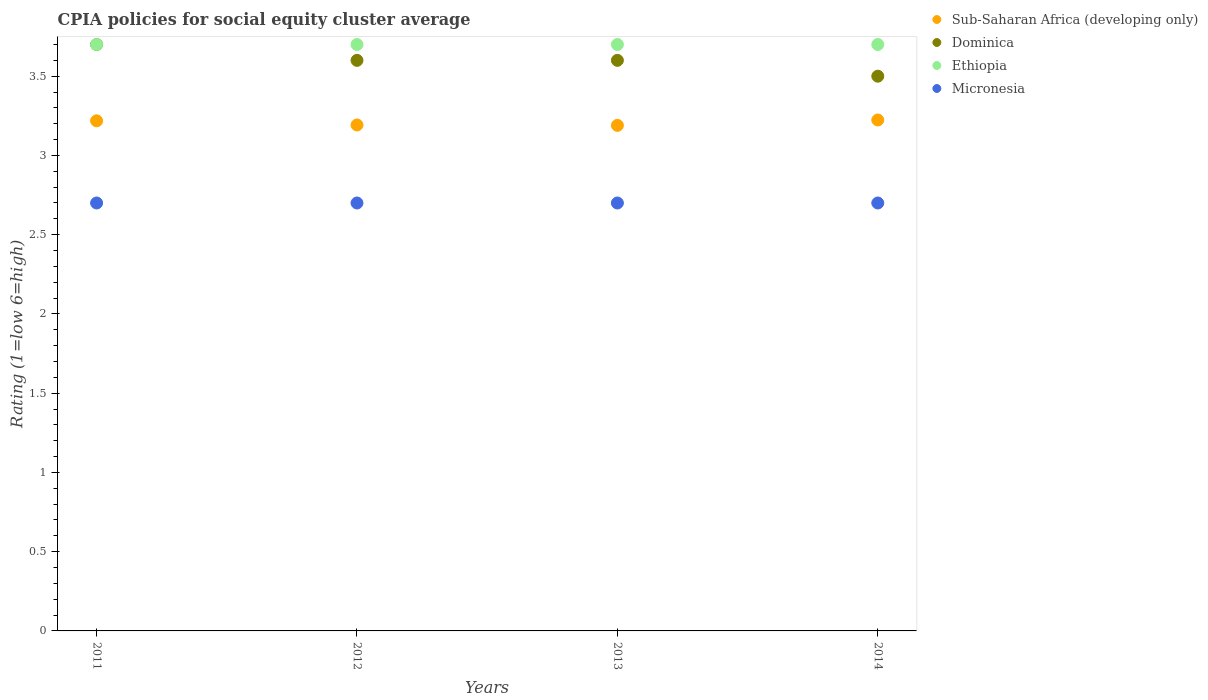How many different coloured dotlines are there?
Ensure brevity in your answer.  4. Is the number of dotlines equal to the number of legend labels?
Provide a succinct answer. Yes. Across all years, what is the maximum CPIA rating in Dominica?
Your answer should be very brief. 3.7. In which year was the CPIA rating in Dominica minimum?
Give a very brief answer. 2014. What is the total CPIA rating in Sub-Saharan Africa (developing only) in the graph?
Provide a short and direct response. 12.82. What is the difference between the CPIA rating in Sub-Saharan Africa (developing only) in 2013 and that in 2014?
Your answer should be very brief. -0.03. What is the difference between the CPIA rating in Micronesia in 2011 and the CPIA rating in Dominica in 2013?
Your response must be concise. -0.9. What is the average CPIA rating in Micronesia per year?
Make the answer very short. 2.7. In the year 2011, what is the difference between the CPIA rating in Ethiopia and CPIA rating in Micronesia?
Give a very brief answer. 1. What is the ratio of the CPIA rating in Dominica in 2013 to that in 2014?
Provide a short and direct response. 1.03. Is the CPIA rating in Micronesia in 2012 less than that in 2014?
Give a very brief answer. No. What is the difference between the highest and the second highest CPIA rating in Micronesia?
Offer a terse response. 0. In how many years, is the CPIA rating in Dominica greater than the average CPIA rating in Dominica taken over all years?
Give a very brief answer. 1. Is the CPIA rating in Sub-Saharan Africa (developing only) strictly greater than the CPIA rating in Micronesia over the years?
Provide a succinct answer. Yes. Is the CPIA rating in Ethiopia strictly less than the CPIA rating in Dominica over the years?
Offer a very short reply. No. How many dotlines are there?
Your response must be concise. 4. What is the difference between two consecutive major ticks on the Y-axis?
Provide a succinct answer. 0.5. Are the values on the major ticks of Y-axis written in scientific E-notation?
Offer a terse response. No. Does the graph contain grids?
Provide a succinct answer. No. Where does the legend appear in the graph?
Your answer should be very brief. Top right. How many legend labels are there?
Your answer should be very brief. 4. How are the legend labels stacked?
Offer a terse response. Vertical. What is the title of the graph?
Your answer should be very brief. CPIA policies for social equity cluster average. Does "Greece" appear as one of the legend labels in the graph?
Your response must be concise. No. What is the label or title of the X-axis?
Your answer should be very brief. Years. What is the label or title of the Y-axis?
Ensure brevity in your answer.  Rating (1=low 6=high). What is the Rating (1=low 6=high) of Sub-Saharan Africa (developing only) in 2011?
Make the answer very short. 3.22. What is the Rating (1=low 6=high) of Ethiopia in 2011?
Provide a short and direct response. 3.7. What is the Rating (1=low 6=high) in Micronesia in 2011?
Make the answer very short. 2.7. What is the Rating (1=low 6=high) of Sub-Saharan Africa (developing only) in 2012?
Offer a very short reply. 3.19. What is the Rating (1=low 6=high) of Sub-Saharan Africa (developing only) in 2013?
Your response must be concise. 3.19. What is the Rating (1=low 6=high) in Dominica in 2013?
Your response must be concise. 3.6. What is the Rating (1=low 6=high) in Sub-Saharan Africa (developing only) in 2014?
Provide a short and direct response. 3.22. What is the Rating (1=low 6=high) in Ethiopia in 2014?
Provide a succinct answer. 3.7. What is the Rating (1=low 6=high) in Micronesia in 2014?
Keep it short and to the point. 2.7. Across all years, what is the maximum Rating (1=low 6=high) of Sub-Saharan Africa (developing only)?
Ensure brevity in your answer.  3.22. Across all years, what is the maximum Rating (1=low 6=high) of Dominica?
Keep it short and to the point. 3.7. Across all years, what is the maximum Rating (1=low 6=high) of Ethiopia?
Provide a short and direct response. 3.7. Across all years, what is the minimum Rating (1=low 6=high) of Sub-Saharan Africa (developing only)?
Your response must be concise. 3.19. Across all years, what is the minimum Rating (1=low 6=high) of Ethiopia?
Offer a very short reply. 3.7. Across all years, what is the minimum Rating (1=low 6=high) of Micronesia?
Your answer should be very brief. 2.7. What is the total Rating (1=low 6=high) in Sub-Saharan Africa (developing only) in the graph?
Offer a very short reply. 12.82. What is the total Rating (1=low 6=high) of Dominica in the graph?
Your answer should be very brief. 14.4. What is the total Rating (1=low 6=high) in Ethiopia in the graph?
Ensure brevity in your answer.  14.8. What is the difference between the Rating (1=low 6=high) of Sub-Saharan Africa (developing only) in 2011 and that in 2012?
Your answer should be very brief. 0.03. What is the difference between the Rating (1=low 6=high) of Sub-Saharan Africa (developing only) in 2011 and that in 2013?
Ensure brevity in your answer.  0.03. What is the difference between the Rating (1=low 6=high) of Dominica in 2011 and that in 2013?
Provide a succinct answer. 0.1. What is the difference between the Rating (1=low 6=high) in Ethiopia in 2011 and that in 2013?
Provide a short and direct response. 0. What is the difference between the Rating (1=low 6=high) of Micronesia in 2011 and that in 2013?
Make the answer very short. 0. What is the difference between the Rating (1=low 6=high) of Sub-Saharan Africa (developing only) in 2011 and that in 2014?
Ensure brevity in your answer.  -0.01. What is the difference between the Rating (1=low 6=high) in Ethiopia in 2011 and that in 2014?
Give a very brief answer. 0. What is the difference between the Rating (1=low 6=high) in Micronesia in 2011 and that in 2014?
Offer a terse response. 0. What is the difference between the Rating (1=low 6=high) in Sub-Saharan Africa (developing only) in 2012 and that in 2013?
Your answer should be compact. 0. What is the difference between the Rating (1=low 6=high) of Dominica in 2012 and that in 2013?
Offer a very short reply. 0. What is the difference between the Rating (1=low 6=high) of Sub-Saharan Africa (developing only) in 2012 and that in 2014?
Offer a terse response. -0.03. What is the difference between the Rating (1=low 6=high) in Micronesia in 2012 and that in 2014?
Offer a terse response. 0. What is the difference between the Rating (1=low 6=high) in Sub-Saharan Africa (developing only) in 2013 and that in 2014?
Offer a terse response. -0.03. What is the difference between the Rating (1=low 6=high) in Dominica in 2013 and that in 2014?
Offer a very short reply. 0.1. What is the difference between the Rating (1=low 6=high) of Micronesia in 2013 and that in 2014?
Provide a short and direct response. 0. What is the difference between the Rating (1=low 6=high) in Sub-Saharan Africa (developing only) in 2011 and the Rating (1=low 6=high) in Dominica in 2012?
Ensure brevity in your answer.  -0.38. What is the difference between the Rating (1=low 6=high) of Sub-Saharan Africa (developing only) in 2011 and the Rating (1=low 6=high) of Ethiopia in 2012?
Offer a very short reply. -0.48. What is the difference between the Rating (1=low 6=high) in Sub-Saharan Africa (developing only) in 2011 and the Rating (1=low 6=high) in Micronesia in 2012?
Offer a terse response. 0.52. What is the difference between the Rating (1=low 6=high) in Dominica in 2011 and the Rating (1=low 6=high) in Ethiopia in 2012?
Ensure brevity in your answer.  0. What is the difference between the Rating (1=low 6=high) of Dominica in 2011 and the Rating (1=low 6=high) of Micronesia in 2012?
Offer a very short reply. 1. What is the difference between the Rating (1=low 6=high) in Sub-Saharan Africa (developing only) in 2011 and the Rating (1=low 6=high) in Dominica in 2013?
Your answer should be very brief. -0.38. What is the difference between the Rating (1=low 6=high) in Sub-Saharan Africa (developing only) in 2011 and the Rating (1=low 6=high) in Ethiopia in 2013?
Provide a succinct answer. -0.48. What is the difference between the Rating (1=low 6=high) in Sub-Saharan Africa (developing only) in 2011 and the Rating (1=low 6=high) in Micronesia in 2013?
Ensure brevity in your answer.  0.52. What is the difference between the Rating (1=low 6=high) of Sub-Saharan Africa (developing only) in 2011 and the Rating (1=low 6=high) of Dominica in 2014?
Offer a very short reply. -0.28. What is the difference between the Rating (1=low 6=high) of Sub-Saharan Africa (developing only) in 2011 and the Rating (1=low 6=high) of Ethiopia in 2014?
Provide a short and direct response. -0.48. What is the difference between the Rating (1=low 6=high) of Sub-Saharan Africa (developing only) in 2011 and the Rating (1=low 6=high) of Micronesia in 2014?
Offer a terse response. 0.52. What is the difference between the Rating (1=low 6=high) in Dominica in 2011 and the Rating (1=low 6=high) in Ethiopia in 2014?
Provide a succinct answer. 0. What is the difference between the Rating (1=low 6=high) of Ethiopia in 2011 and the Rating (1=low 6=high) of Micronesia in 2014?
Offer a very short reply. 1. What is the difference between the Rating (1=low 6=high) in Sub-Saharan Africa (developing only) in 2012 and the Rating (1=low 6=high) in Dominica in 2013?
Give a very brief answer. -0.41. What is the difference between the Rating (1=low 6=high) in Sub-Saharan Africa (developing only) in 2012 and the Rating (1=low 6=high) in Ethiopia in 2013?
Keep it short and to the point. -0.51. What is the difference between the Rating (1=low 6=high) of Sub-Saharan Africa (developing only) in 2012 and the Rating (1=low 6=high) of Micronesia in 2013?
Provide a succinct answer. 0.49. What is the difference between the Rating (1=low 6=high) in Dominica in 2012 and the Rating (1=low 6=high) in Ethiopia in 2013?
Your answer should be compact. -0.1. What is the difference between the Rating (1=low 6=high) in Dominica in 2012 and the Rating (1=low 6=high) in Micronesia in 2013?
Provide a short and direct response. 0.9. What is the difference between the Rating (1=low 6=high) in Sub-Saharan Africa (developing only) in 2012 and the Rating (1=low 6=high) in Dominica in 2014?
Your answer should be compact. -0.31. What is the difference between the Rating (1=low 6=high) in Sub-Saharan Africa (developing only) in 2012 and the Rating (1=low 6=high) in Ethiopia in 2014?
Keep it short and to the point. -0.51. What is the difference between the Rating (1=low 6=high) in Sub-Saharan Africa (developing only) in 2012 and the Rating (1=low 6=high) in Micronesia in 2014?
Provide a short and direct response. 0.49. What is the difference between the Rating (1=low 6=high) of Dominica in 2012 and the Rating (1=low 6=high) of Ethiopia in 2014?
Provide a succinct answer. -0.1. What is the difference between the Rating (1=low 6=high) of Dominica in 2012 and the Rating (1=low 6=high) of Micronesia in 2014?
Provide a short and direct response. 0.9. What is the difference between the Rating (1=low 6=high) of Sub-Saharan Africa (developing only) in 2013 and the Rating (1=low 6=high) of Dominica in 2014?
Your answer should be compact. -0.31. What is the difference between the Rating (1=low 6=high) in Sub-Saharan Africa (developing only) in 2013 and the Rating (1=low 6=high) in Ethiopia in 2014?
Your answer should be compact. -0.51. What is the difference between the Rating (1=low 6=high) in Sub-Saharan Africa (developing only) in 2013 and the Rating (1=low 6=high) in Micronesia in 2014?
Keep it short and to the point. 0.49. What is the difference between the Rating (1=low 6=high) of Dominica in 2013 and the Rating (1=low 6=high) of Ethiopia in 2014?
Your answer should be very brief. -0.1. What is the average Rating (1=low 6=high) of Sub-Saharan Africa (developing only) per year?
Give a very brief answer. 3.21. What is the average Rating (1=low 6=high) in Ethiopia per year?
Provide a short and direct response. 3.7. What is the average Rating (1=low 6=high) in Micronesia per year?
Offer a terse response. 2.7. In the year 2011, what is the difference between the Rating (1=low 6=high) in Sub-Saharan Africa (developing only) and Rating (1=low 6=high) in Dominica?
Your response must be concise. -0.48. In the year 2011, what is the difference between the Rating (1=low 6=high) of Sub-Saharan Africa (developing only) and Rating (1=low 6=high) of Ethiopia?
Provide a succinct answer. -0.48. In the year 2011, what is the difference between the Rating (1=low 6=high) in Sub-Saharan Africa (developing only) and Rating (1=low 6=high) in Micronesia?
Provide a short and direct response. 0.52. In the year 2011, what is the difference between the Rating (1=low 6=high) in Ethiopia and Rating (1=low 6=high) in Micronesia?
Give a very brief answer. 1. In the year 2012, what is the difference between the Rating (1=low 6=high) of Sub-Saharan Africa (developing only) and Rating (1=low 6=high) of Dominica?
Ensure brevity in your answer.  -0.41. In the year 2012, what is the difference between the Rating (1=low 6=high) of Sub-Saharan Africa (developing only) and Rating (1=low 6=high) of Ethiopia?
Offer a terse response. -0.51. In the year 2012, what is the difference between the Rating (1=low 6=high) of Sub-Saharan Africa (developing only) and Rating (1=low 6=high) of Micronesia?
Give a very brief answer. 0.49. In the year 2012, what is the difference between the Rating (1=low 6=high) of Dominica and Rating (1=low 6=high) of Ethiopia?
Ensure brevity in your answer.  -0.1. In the year 2012, what is the difference between the Rating (1=low 6=high) in Dominica and Rating (1=low 6=high) in Micronesia?
Make the answer very short. 0.9. In the year 2013, what is the difference between the Rating (1=low 6=high) of Sub-Saharan Africa (developing only) and Rating (1=low 6=high) of Dominica?
Provide a succinct answer. -0.41. In the year 2013, what is the difference between the Rating (1=low 6=high) in Sub-Saharan Africa (developing only) and Rating (1=low 6=high) in Ethiopia?
Your response must be concise. -0.51. In the year 2013, what is the difference between the Rating (1=low 6=high) of Sub-Saharan Africa (developing only) and Rating (1=low 6=high) of Micronesia?
Your response must be concise. 0.49. In the year 2013, what is the difference between the Rating (1=low 6=high) in Dominica and Rating (1=low 6=high) in Micronesia?
Make the answer very short. 0.9. In the year 2013, what is the difference between the Rating (1=low 6=high) in Ethiopia and Rating (1=low 6=high) in Micronesia?
Your answer should be very brief. 1. In the year 2014, what is the difference between the Rating (1=low 6=high) in Sub-Saharan Africa (developing only) and Rating (1=low 6=high) in Dominica?
Ensure brevity in your answer.  -0.28. In the year 2014, what is the difference between the Rating (1=low 6=high) in Sub-Saharan Africa (developing only) and Rating (1=low 6=high) in Ethiopia?
Your answer should be compact. -0.48. In the year 2014, what is the difference between the Rating (1=low 6=high) of Sub-Saharan Africa (developing only) and Rating (1=low 6=high) of Micronesia?
Offer a very short reply. 0.52. What is the ratio of the Rating (1=low 6=high) in Sub-Saharan Africa (developing only) in 2011 to that in 2012?
Ensure brevity in your answer.  1.01. What is the ratio of the Rating (1=low 6=high) of Dominica in 2011 to that in 2012?
Offer a terse response. 1.03. What is the ratio of the Rating (1=low 6=high) of Micronesia in 2011 to that in 2012?
Your answer should be compact. 1. What is the ratio of the Rating (1=low 6=high) in Sub-Saharan Africa (developing only) in 2011 to that in 2013?
Give a very brief answer. 1.01. What is the ratio of the Rating (1=low 6=high) of Dominica in 2011 to that in 2013?
Give a very brief answer. 1.03. What is the ratio of the Rating (1=low 6=high) of Ethiopia in 2011 to that in 2013?
Make the answer very short. 1. What is the ratio of the Rating (1=low 6=high) of Micronesia in 2011 to that in 2013?
Give a very brief answer. 1. What is the ratio of the Rating (1=low 6=high) in Sub-Saharan Africa (developing only) in 2011 to that in 2014?
Offer a terse response. 1. What is the ratio of the Rating (1=low 6=high) in Dominica in 2011 to that in 2014?
Provide a short and direct response. 1.06. What is the ratio of the Rating (1=low 6=high) of Ethiopia in 2011 to that in 2014?
Give a very brief answer. 1. What is the ratio of the Rating (1=low 6=high) in Micronesia in 2011 to that in 2014?
Make the answer very short. 1. What is the ratio of the Rating (1=low 6=high) of Sub-Saharan Africa (developing only) in 2012 to that in 2013?
Keep it short and to the point. 1. What is the ratio of the Rating (1=low 6=high) of Micronesia in 2012 to that in 2013?
Your answer should be very brief. 1. What is the ratio of the Rating (1=low 6=high) of Sub-Saharan Africa (developing only) in 2012 to that in 2014?
Your response must be concise. 0.99. What is the ratio of the Rating (1=low 6=high) in Dominica in 2012 to that in 2014?
Provide a succinct answer. 1.03. What is the ratio of the Rating (1=low 6=high) in Micronesia in 2012 to that in 2014?
Your answer should be very brief. 1. What is the ratio of the Rating (1=low 6=high) of Dominica in 2013 to that in 2014?
Your answer should be compact. 1.03. What is the ratio of the Rating (1=low 6=high) of Ethiopia in 2013 to that in 2014?
Provide a short and direct response. 1. What is the ratio of the Rating (1=low 6=high) of Micronesia in 2013 to that in 2014?
Make the answer very short. 1. What is the difference between the highest and the second highest Rating (1=low 6=high) in Sub-Saharan Africa (developing only)?
Offer a very short reply. 0.01. What is the difference between the highest and the second highest Rating (1=low 6=high) in Dominica?
Your response must be concise. 0.1. What is the difference between the highest and the second highest Rating (1=low 6=high) of Ethiopia?
Your answer should be compact. 0. What is the difference between the highest and the second highest Rating (1=low 6=high) in Micronesia?
Ensure brevity in your answer.  0. What is the difference between the highest and the lowest Rating (1=low 6=high) of Sub-Saharan Africa (developing only)?
Your answer should be compact. 0.03. What is the difference between the highest and the lowest Rating (1=low 6=high) of Dominica?
Offer a very short reply. 0.2. What is the difference between the highest and the lowest Rating (1=low 6=high) of Micronesia?
Make the answer very short. 0. 